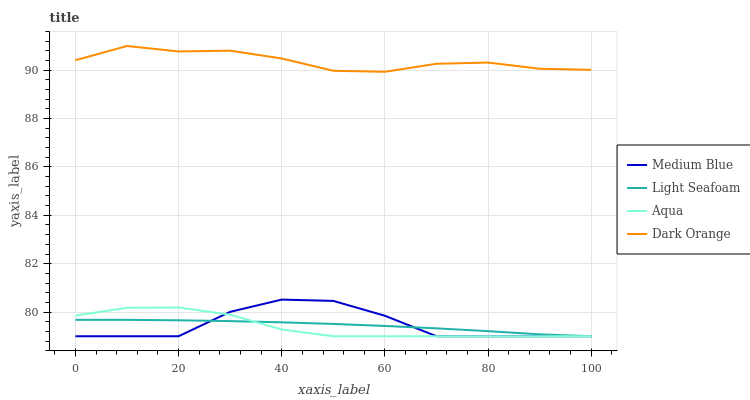Does Aqua have the minimum area under the curve?
Answer yes or no. Yes. Does Dark Orange have the maximum area under the curve?
Answer yes or no. Yes. Does Light Seafoam have the minimum area under the curve?
Answer yes or no. No. Does Light Seafoam have the maximum area under the curve?
Answer yes or no. No. Is Light Seafoam the smoothest?
Answer yes or no. Yes. Is Medium Blue the roughest?
Answer yes or no. Yes. Is Medium Blue the smoothest?
Answer yes or no. No. Is Light Seafoam the roughest?
Answer yes or no. No. Does Aqua have the lowest value?
Answer yes or no. Yes. Does Dark Orange have the lowest value?
Answer yes or no. No. Does Dark Orange have the highest value?
Answer yes or no. Yes. Does Medium Blue have the highest value?
Answer yes or no. No. Is Medium Blue less than Dark Orange?
Answer yes or no. Yes. Is Dark Orange greater than Aqua?
Answer yes or no. Yes. Does Medium Blue intersect Aqua?
Answer yes or no. Yes. Is Medium Blue less than Aqua?
Answer yes or no. No. Is Medium Blue greater than Aqua?
Answer yes or no. No. Does Medium Blue intersect Dark Orange?
Answer yes or no. No. 